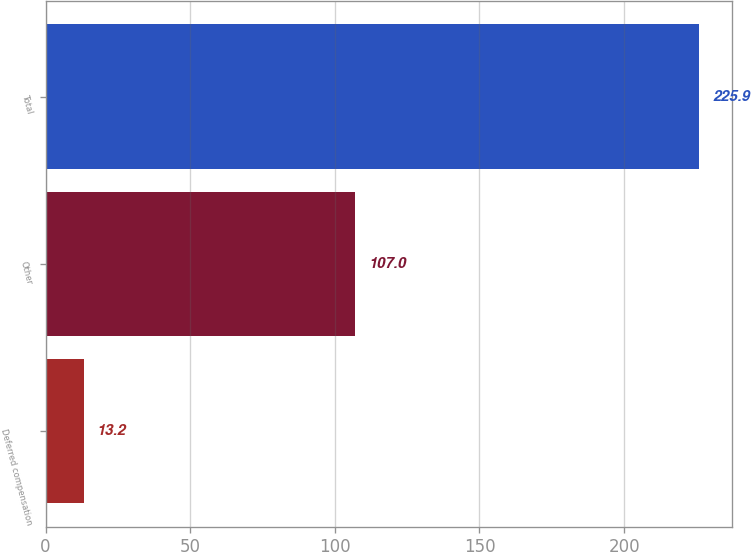Convert chart to OTSL. <chart><loc_0><loc_0><loc_500><loc_500><bar_chart><fcel>Deferred compensation<fcel>Other<fcel>Total<nl><fcel>13.2<fcel>107<fcel>225.9<nl></chart> 